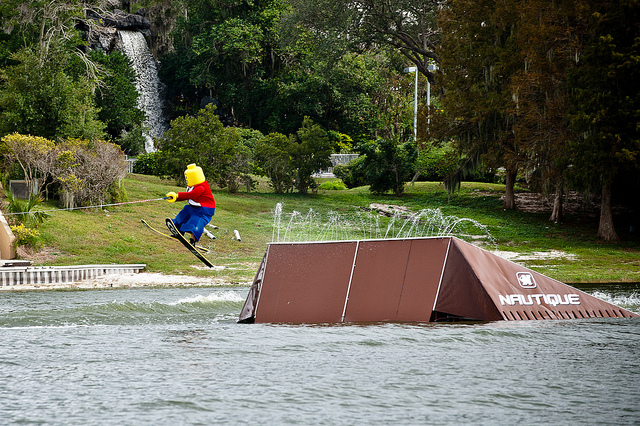Please transcribe the text in this image. NRUTIQUE 